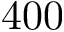<formula> <loc_0><loc_0><loc_500><loc_500>4 0 0</formula> 